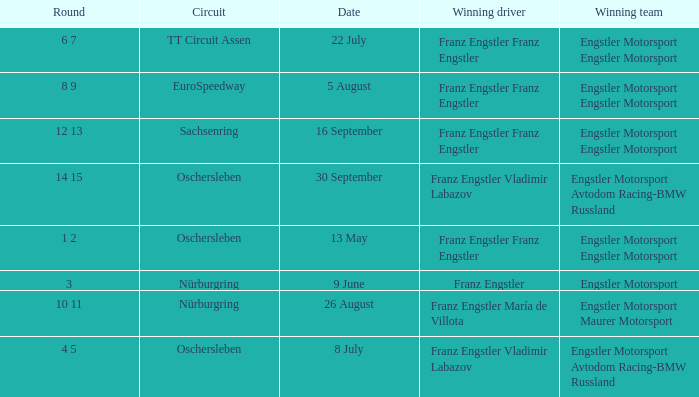Who is the Winning Driver that has a Winning team of Engstler Motorsport Engstler Motorsport and also the Date 22 July? Franz Engstler Franz Engstler. 